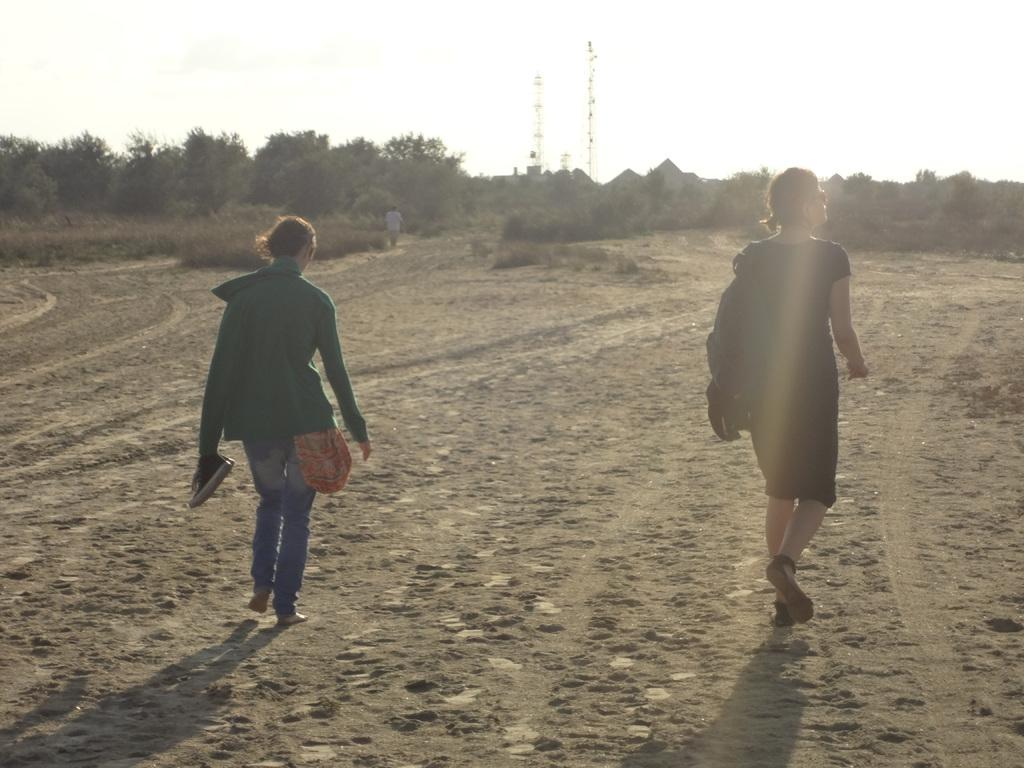How many girls are in the image? There are two girls in the image. Where are the girls positioned in the image? The girls are on the right and left side of the image. What are the girls doing in the image? The girls are walking. What can be seen at the top side of the image? There are trees at the top side of the image. What type of beam is holding up the trees in the image? There is no beam present in the image; the trees are not supported by any visible structure. 